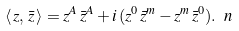<formula> <loc_0><loc_0><loc_500><loc_500>\langle \, z , \, \bar { z } \, \rangle = z ^ { A } \, \bar { z } ^ { A } + i \, ( z ^ { 0 } \, \bar { z } ^ { m } - z ^ { m } \, \bar { z } ^ { 0 } ) . \ n</formula> 